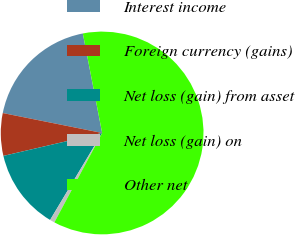Convert chart to OTSL. <chart><loc_0><loc_0><loc_500><loc_500><pie_chart><fcel>Interest income<fcel>Foreign currency (gains)<fcel>Net loss (gain) from asset<fcel>Net loss (gain) on<fcel>Other net<nl><fcel>18.8%<fcel>6.78%<fcel>12.79%<fcel>0.77%<fcel>60.86%<nl></chart> 